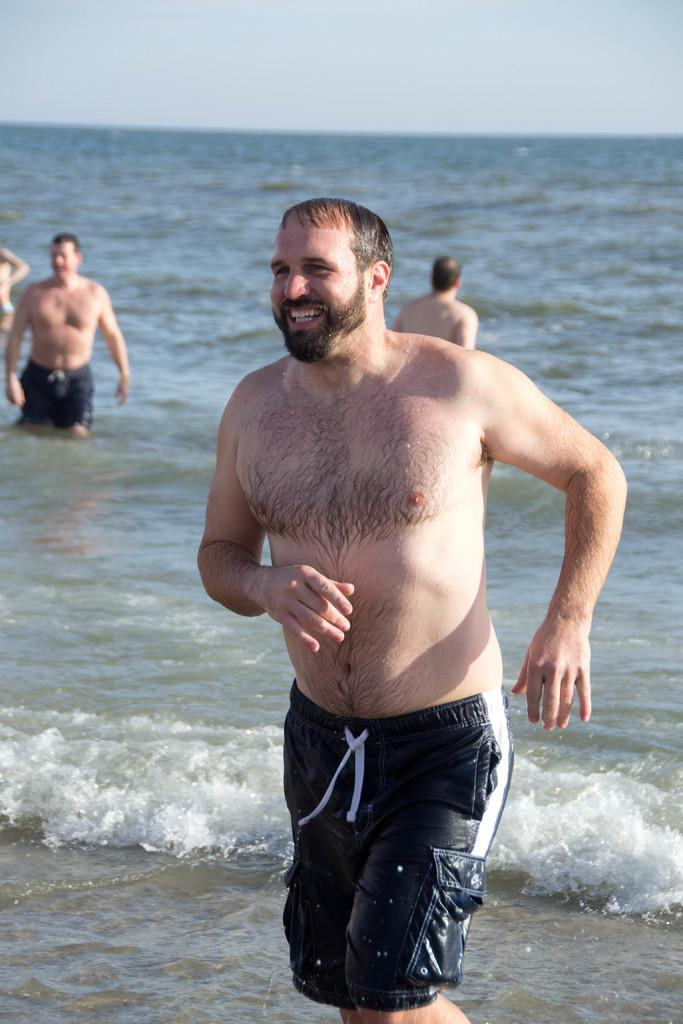What are the men in the image doing? The men in the image are standing in the water. How do the men appear to be feeling? The men have smiles on their faces, indicating that they are happy or enjoying themselves. What is the condition of the sky in the image? The sky is cloudy in the image. What type of chain can be seen connecting the men in the image? There is no chain present in the image; the men are standing in the water without any visible connections between them. 